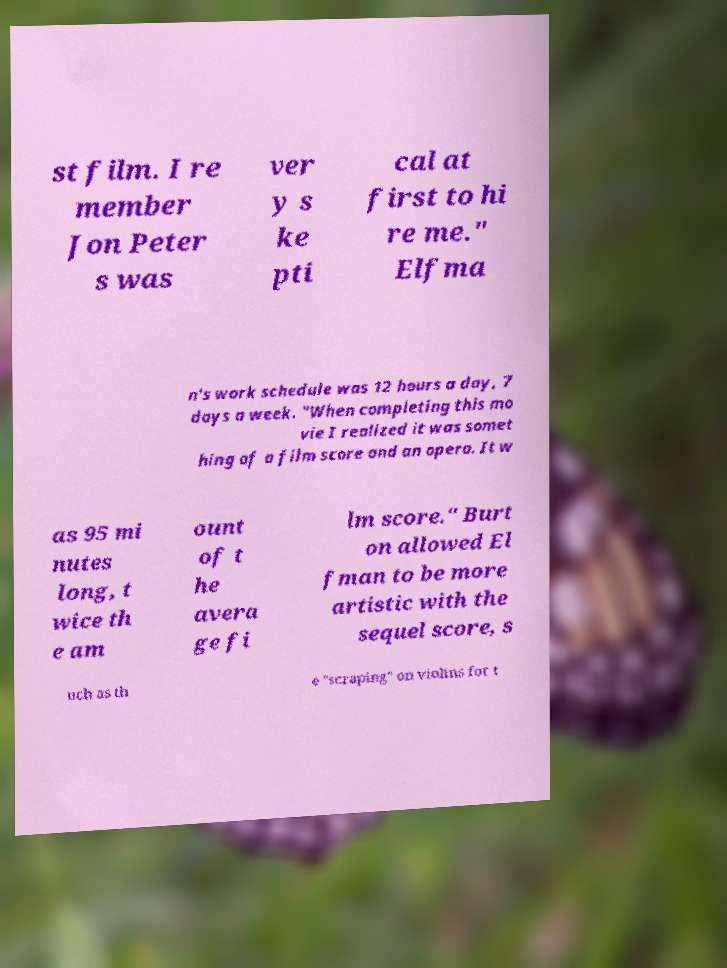Could you assist in decoding the text presented in this image and type it out clearly? st film. I re member Jon Peter s was ver y s ke pti cal at first to hi re me." Elfma n's work schedule was 12 hours a day, 7 days a week. "When completing this mo vie I realized it was somet hing of a film score and an opera. It w as 95 mi nutes long, t wice th e am ount of t he avera ge fi lm score." Burt on allowed El fman to be more artistic with the sequel score, s uch as th e "scraping" on violins for t 